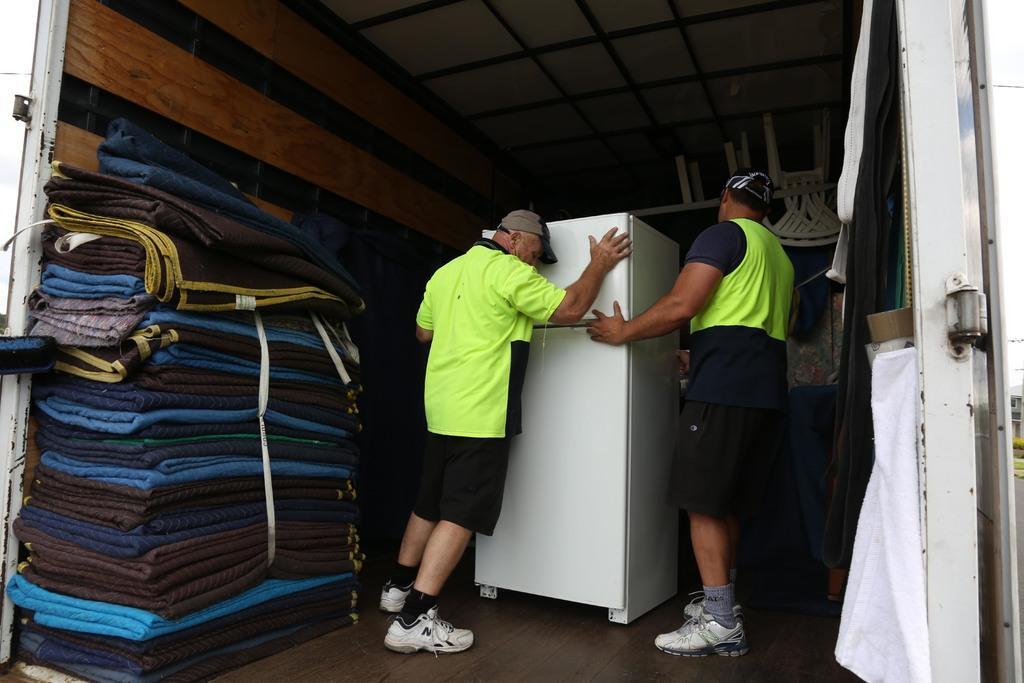Describe this image in one or two sentences. In the image we can see a vehicle. In the vehicle two persons are standing and holding a refrigerator. Behind the refrigerator we can see some chairs and tables. At the top of the image we can see roof. In the bottom left corner of the image we can see some mats. Behind the vehicle we can see some clouds in the sky. 